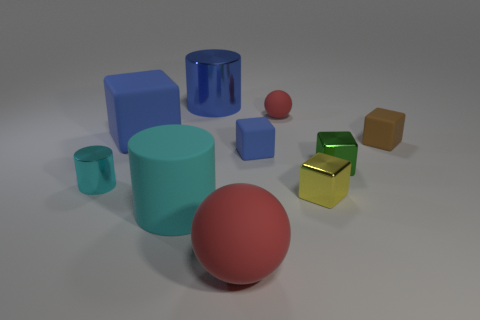How big is the metallic cylinder that is on the right side of the metal cylinder that is to the left of the cylinder that is behind the brown object?
Ensure brevity in your answer.  Large. There is another thing that is the same shape as the large red matte thing; what is its size?
Your response must be concise. Small. How many big objects are either objects or yellow things?
Your answer should be compact. 4. Do the big cylinder behind the small green block and the red sphere that is behind the tiny yellow object have the same material?
Your response must be concise. No. There is a large object left of the rubber cylinder; what material is it?
Your answer should be compact. Rubber. How many shiny objects are either tiny balls or small things?
Offer a terse response. 3. There is a small shiny block on the left side of the small metal block that is behind the small yellow metal thing; what is its color?
Give a very brief answer. Yellow. Is the material of the small red sphere the same as the cyan object behind the yellow metal thing?
Give a very brief answer. No. The metal cylinder that is in front of the rubber sphere that is behind the red ball in front of the tiny blue matte cube is what color?
Your response must be concise. Cyan. Is there anything else that is the same shape as the tiny blue matte object?
Offer a very short reply. Yes. 